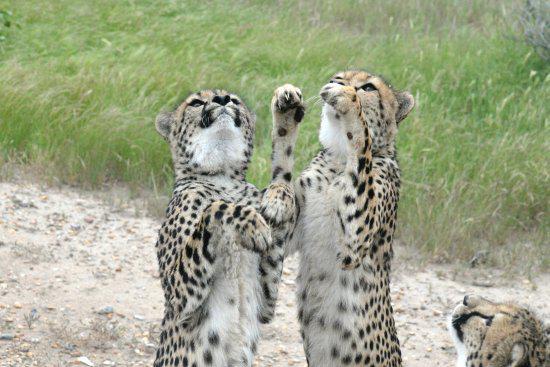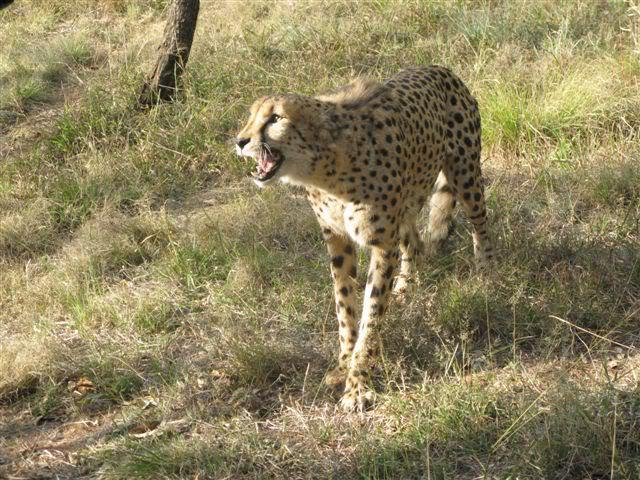The first image is the image on the left, the second image is the image on the right. For the images shown, is this caption "One cheetah's teeth are visible." true? Answer yes or no. Yes. The first image is the image on the left, the second image is the image on the right. Given the left and right images, does the statement "The left image shows a forward angled adult cheetah on the grass on its haunches with a piece of red flesh in front of it." hold true? Answer yes or no. No. 